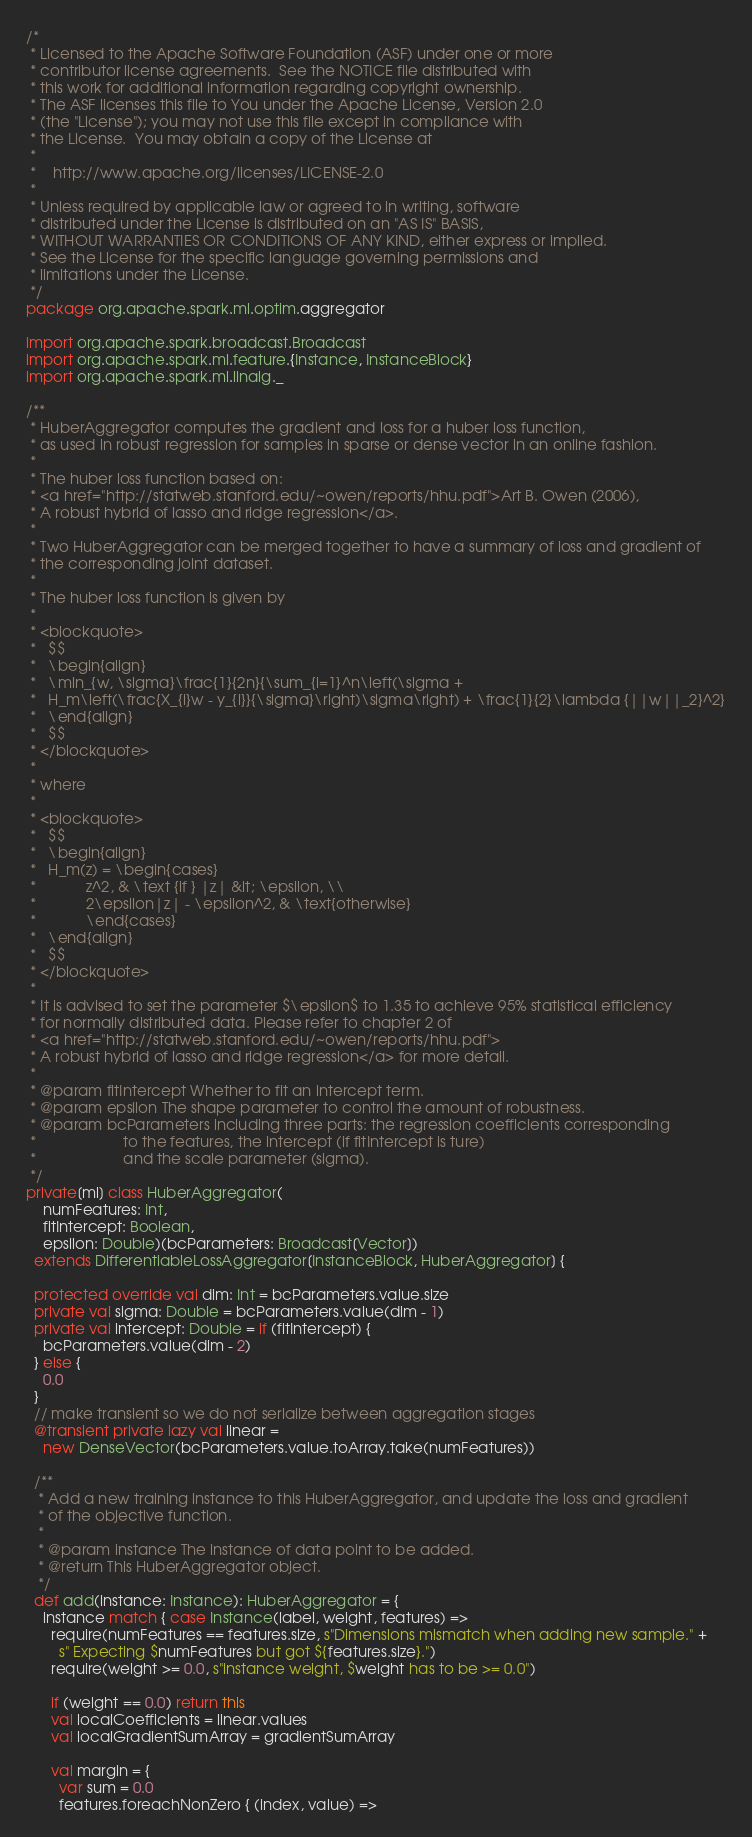<code> <loc_0><loc_0><loc_500><loc_500><_Scala_>/*
 * Licensed to the Apache Software Foundation (ASF) under one or more
 * contributor license agreements.  See the NOTICE file distributed with
 * this work for additional information regarding copyright ownership.
 * The ASF licenses this file to You under the Apache License, Version 2.0
 * (the "License"); you may not use this file except in compliance with
 * the License.  You may obtain a copy of the License at
 *
 *    http://www.apache.org/licenses/LICENSE-2.0
 *
 * Unless required by applicable law or agreed to in writing, software
 * distributed under the License is distributed on an "AS IS" BASIS,
 * WITHOUT WARRANTIES OR CONDITIONS OF ANY KIND, either express or implied.
 * See the License for the specific language governing permissions and
 * limitations under the License.
 */
package org.apache.spark.ml.optim.aggregator

import org.apache.spark.broadcast.Broadcast
import org.apache.spark.ml.feature.{Instance, InstanceBlock}
import org.apache.spark.ml.linalg._

/**
 * HuberAggregator computes the gradient and loss for a huber loss function,
 * as used in robust regression for samples in sparse or dense vector in an online fashion.
 *
 * The huber loss function based on:
 * <a href="http://statweb.stanford.edu/~owen/reports/hhu.pdf">Art B. Owen (2006),
 * A robust hybrid of lasso and ridge regression</a>.
 *
 * Two HuberAggregator can be merged together to have a summary of loss and gradient of
 * the corresponding joint dataset.
 *
 * The huber loss function is given by
 *
 * <blockquote>
 *   $$
 *   \begin{align}
 *   \min_{w, \sigma}\frac{1}{2n}{\sum_{i=1}^n\left(\sigma +
 *   H_m\left(\frac{X_{i}w - y_{i}}{\sigma}\right)\sigma\right) + \frac{1}{2}\lambda {||w||_2}^2}
 *   \end{align}
 *   $$
 * </blockquote>
 *
 * where
 *
 * <blockquote>
 *   $$
 *   \begin{align}
 *   H_m(z) = \begin{cases}
 *            z^2, & \text {if } |z| &lt; \epsilon, \\
 *            2\epsilon|z| - \epsilon^2, & \text{otherwise}
 *            \end{cases}
 *   \end{align}
 *   $$
 * </blockquote>
 *
 * It is advised to set the parameter $\epsilon$ to 1.35 to achieve 95% statistical efficiency
 * for normally distributed data. Please refer to chapter 2 of
 * <a href="http://statweb.stanford.edu/~owen/reports/hhu.pdf">
 * A robust hybrid of lasso and ridge regression</a> for more detail.
 *
 * @param fitIntercept Whether to fit an intercept term.
 * @param epsilon The shape parameter to control the amount of robustness.
 * @param bcParameters including three parts: the regression coefficients corresponding
 *                     to the features, the intercept (if fitIntercept is ture)
 *                     and the scale parameter (sigma).
 */
private[ml] class HuberAggregator(
    numFeatures: Int,
    fitIntercept: Boolean,
    epsilon: Double)(bcParameters: Broadcast[Vector])
  extends DifferentiableLossAggregator[InstanceBlock, HuberAggregator] {

  protected override val dim: Int = bcParameters.value.size
  private val sigma: Double = bcParameters.value(dim - 1)
  private val intercept: Double = if (fitIntercept) {
    bcParameters.value(dim - 2)
  } else {
    0.0
  }
  // make transient so we do not serialize between aggregation stages
  @transient private lazy val linear =
    new DenseVector(bcParameters.value.toArray.take(numFeatures))

  /**
   * Add a new training instance to this HuberAggregator, and update the loss and gradient
   * of the objective function.
   *
   * @param instance The instance of data point to be added.
   * @return This HuberAggregator object.
   */
  def add(instance: Instance): HuberAggregator = {
    instance match { case Instance(label, weight, features) =>
      require(numFeatures == features.size, s"Dimensions mismatch when adding new sample." +
        s" Expecting $numFeatures but got ${features.size}.")
      require(weight >= 0.0, s"instance weight, $weight has to be >= 0.0")

      if (weight == 0.0) return this
      val localCoefficients = linear.values
      val localGradientSumArray = gradientSumArray

      val margin = {
        var sum = 0.0
        features.foreachNonZero { (index, value) =></code> 